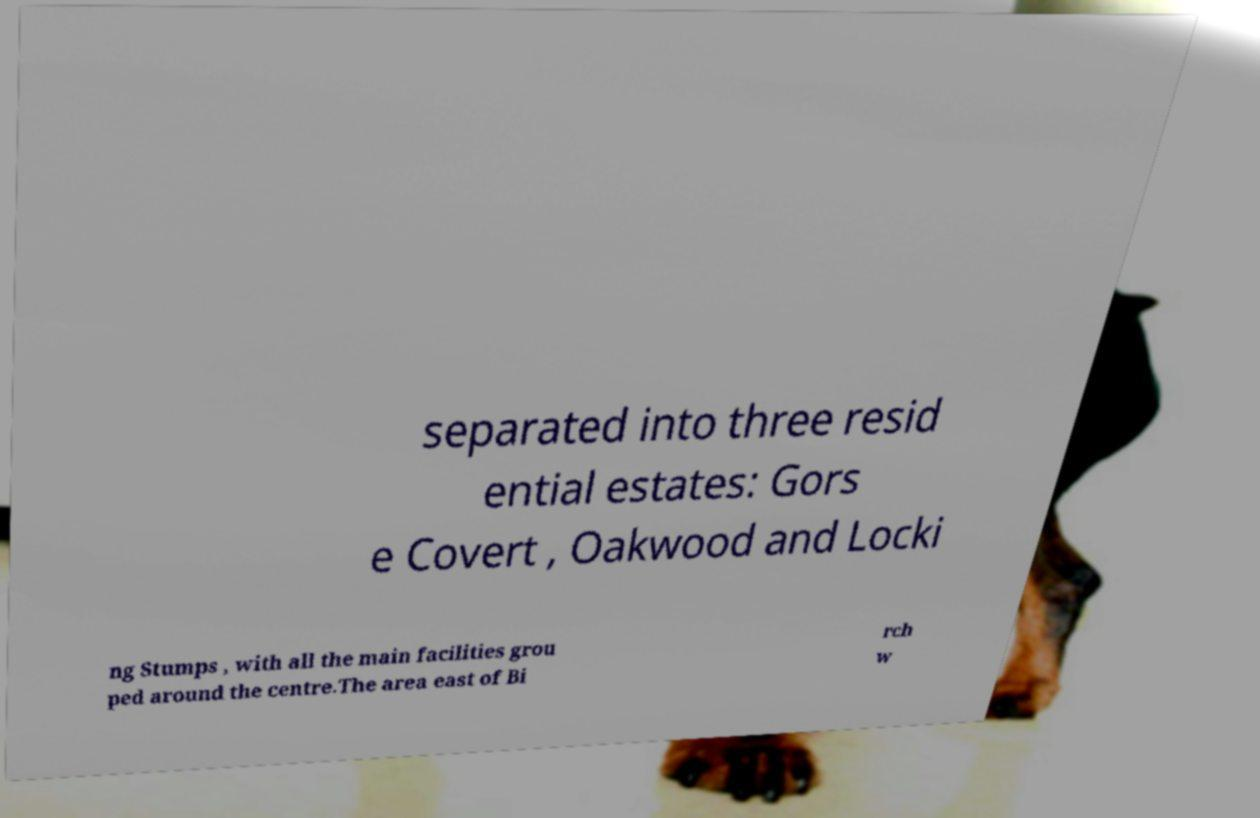I need the written content from this picture converted into text. Can you do that? separated into three resid ential estates: Gors e Covert , Oakwood and Locki ng Stumps , with all the main facilities grou ped around the centre.The area east of Bi rch w 